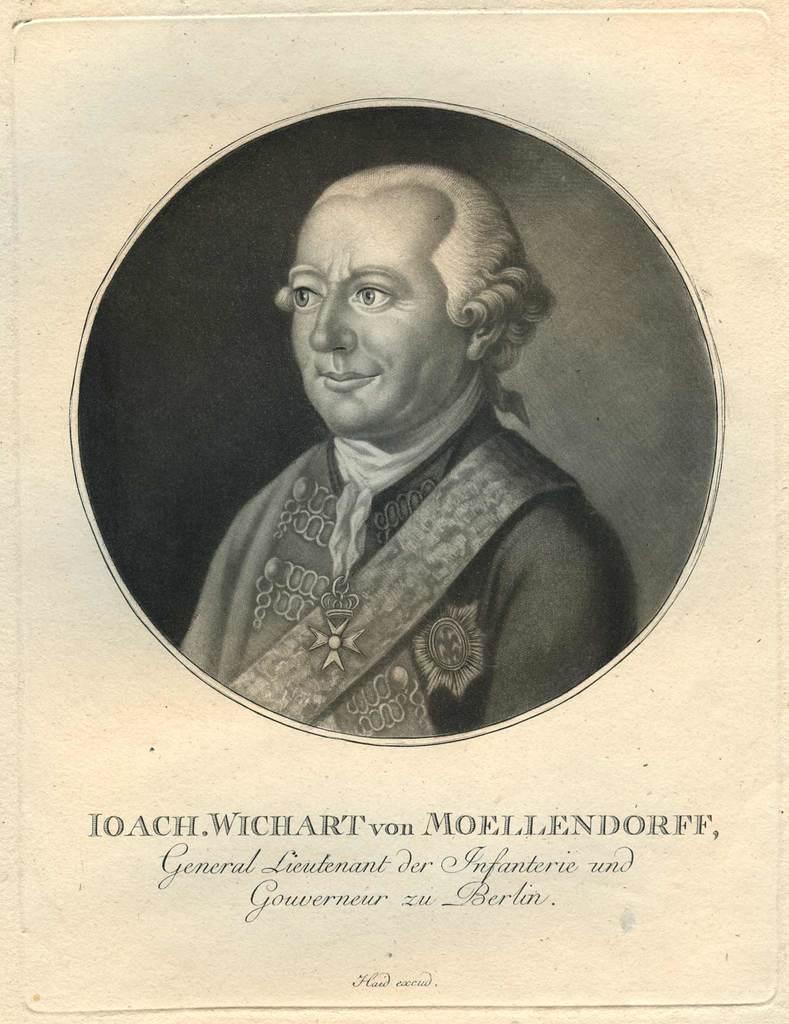In one or two sentences, can you explain what this image depicts? In this image there is an image of a person and some text on the paper. 